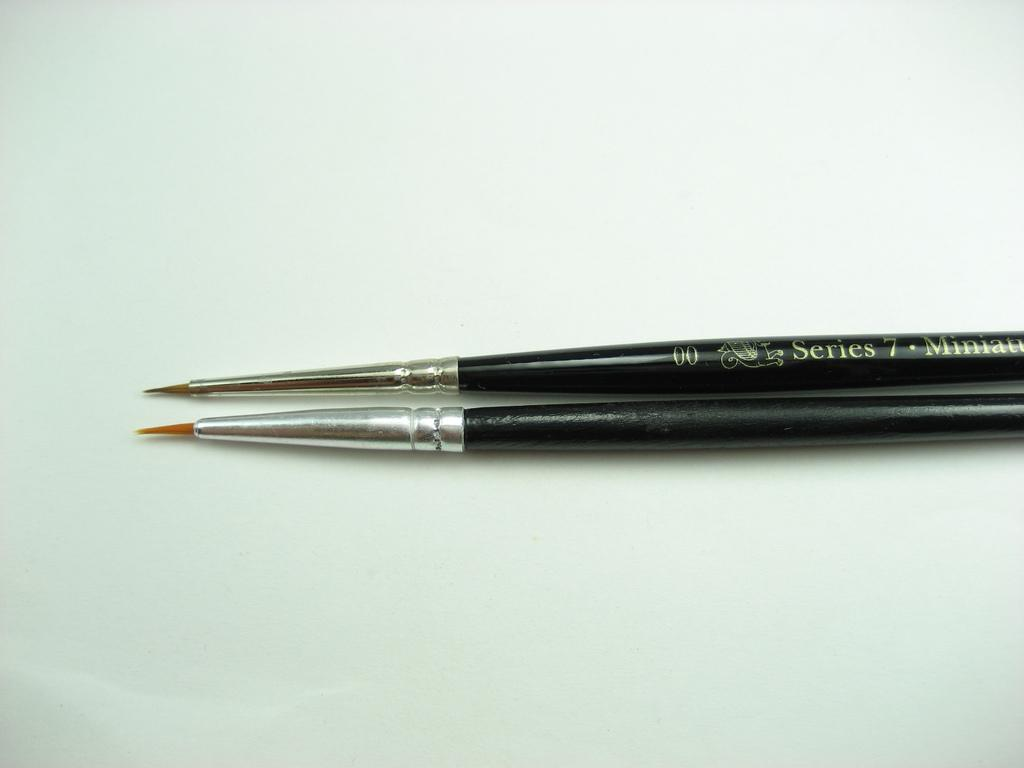What objects are present in the image? There are paint brushes in the image. What color are the paint brushes? The paint brushes are black in color. What color is the background of the image? The background of the image is white. What type of prose can be seen written on the paint brushes in the image? There is no prose present on the paint brushes in the image; they are simply black paint brushes. 